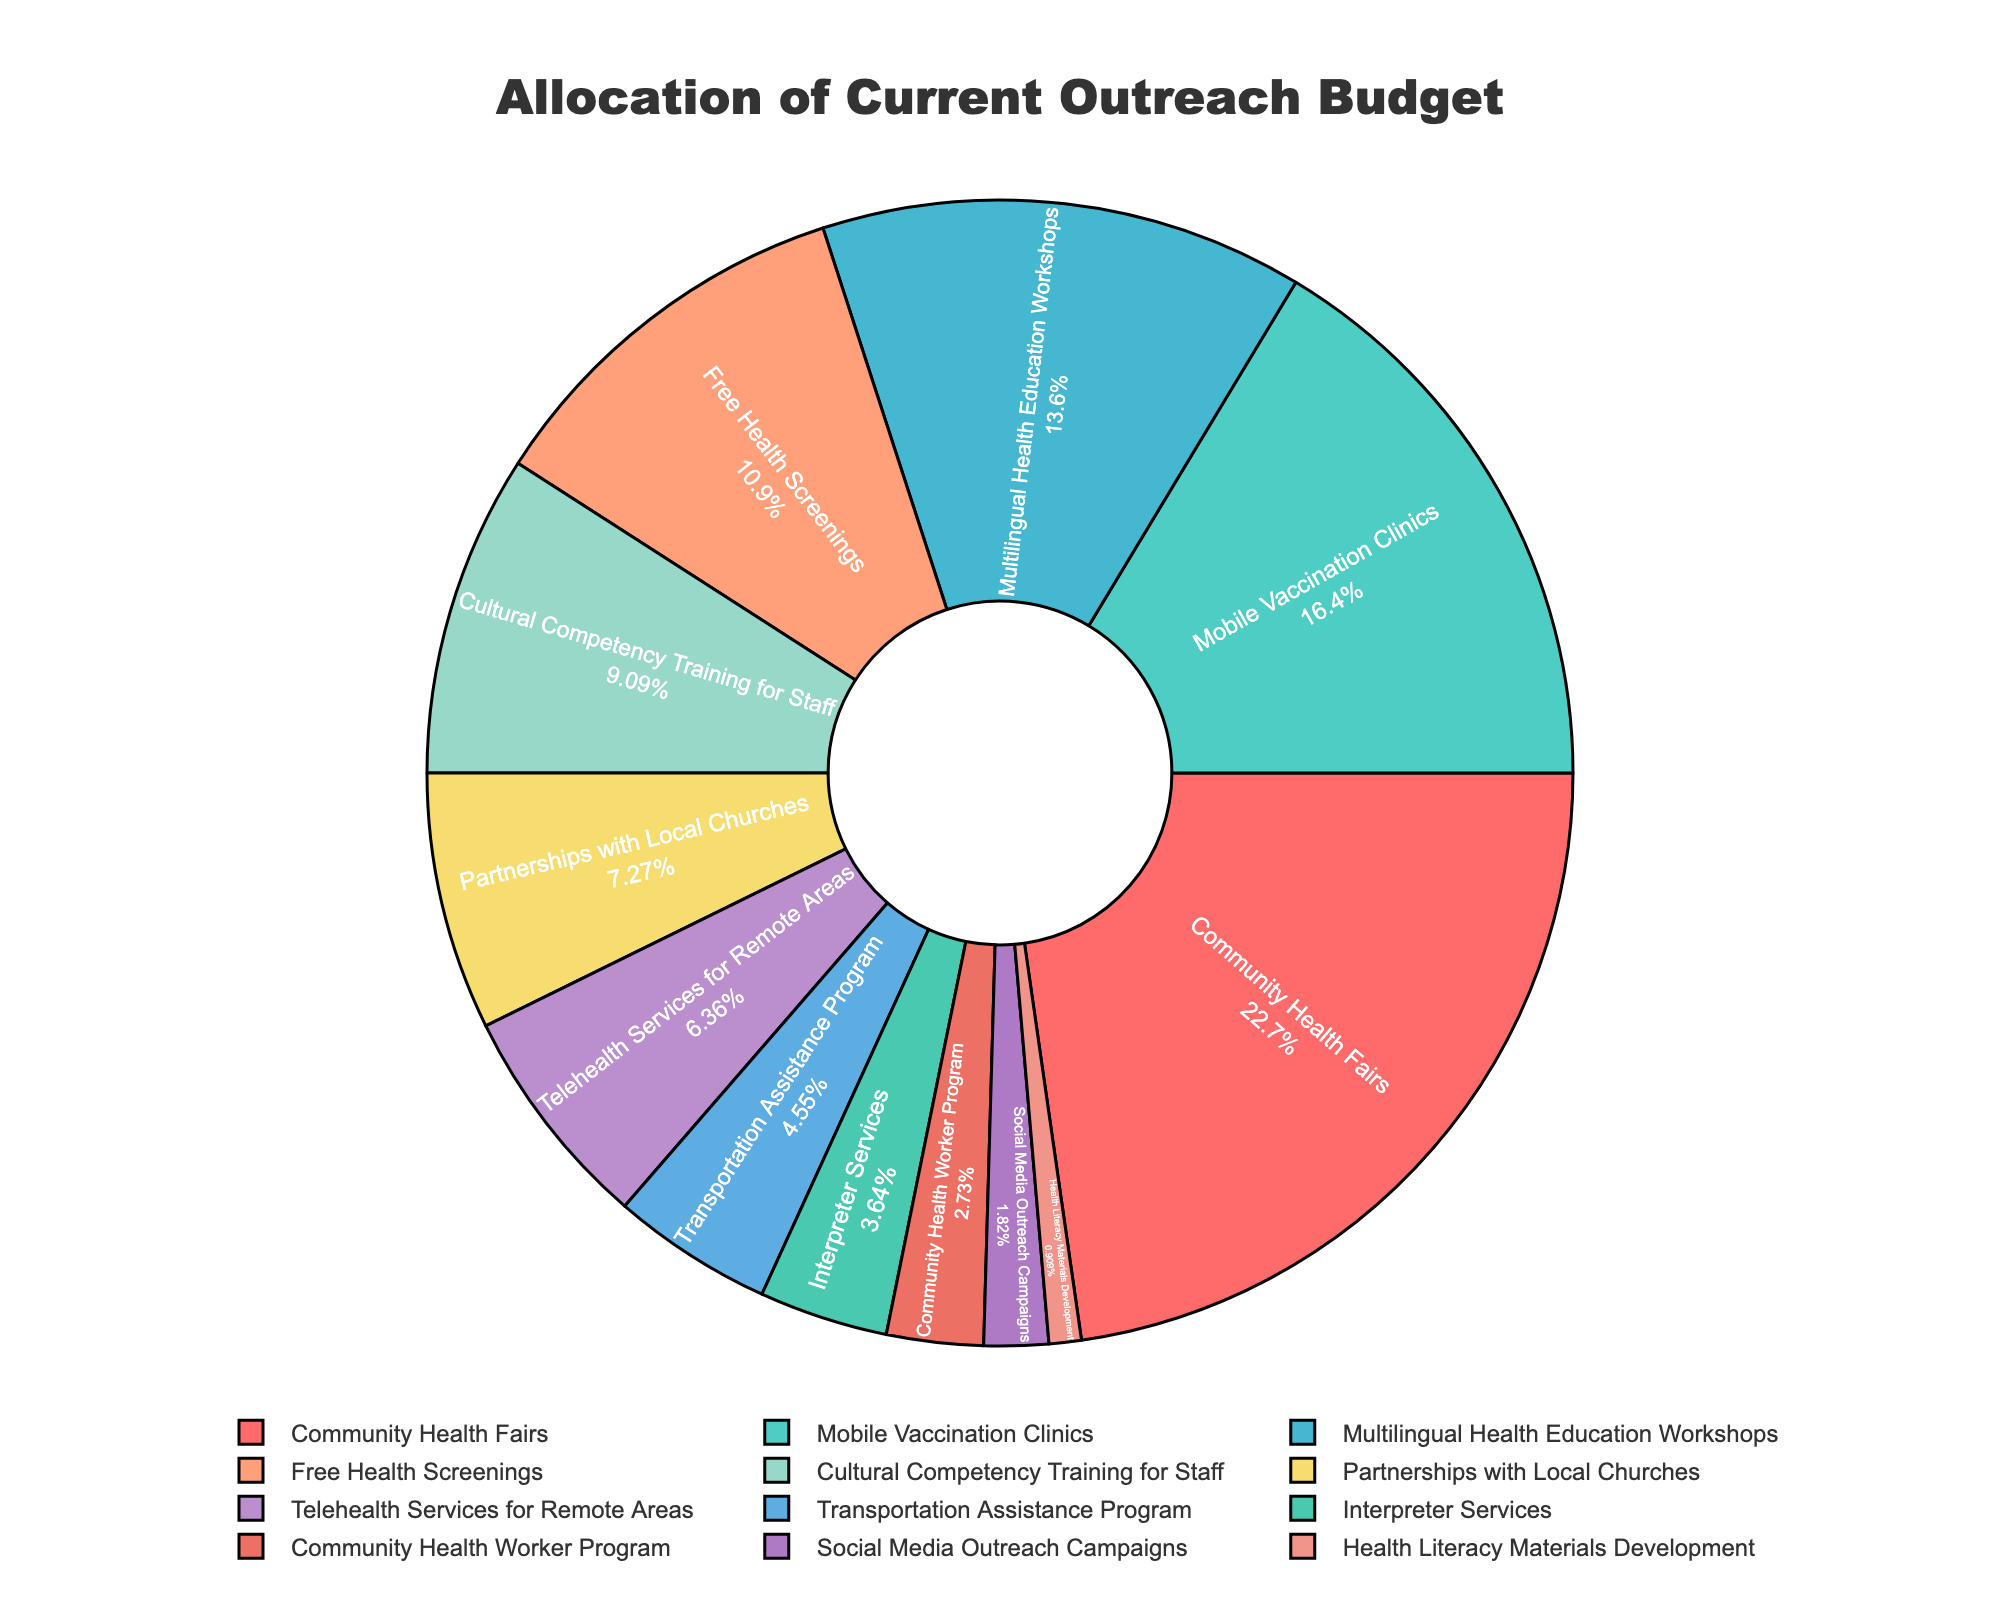What percentage of the total budget is allocated to Mobile Vaccination Clinics? The pie chart shows the percentage of the budget allocated to each program. Locate Mobile Vaccination Clinics, which is labeled inside the pie chart with its percentage.
Answer: 18% Which program has the smallest allocation and what is it? Look for the segment with the smallest percentage in the pie chart. The smallest segment will indicate the program with the least budget allocation.
Answer: Health Literacy Materials Development, 1% Are Community Health Fairs allocated more than double the budget of Interpreter Services? Compare the percentages of Community Health Fairs and Interpreter Services in the pie chart. Community Health Fairs have 25% and Interpreter Services have 4%. Double of Interpreter Services' budget is 8%. 25% > 8%.
Answer: Yes How much more budget is given to Free Health Screenings compared to Transportation Assistance Program? Identify the percentages for both programs on the pie chart. Free Health Screenings have 12% and Transportation Assistance Program has 5%. Calculate the difference: 12% - 5% = 7%.
Answer: 7% Which programs have an allocation percentage between 10% and 20%? Identify programs on the pie chart which have percentages between 10% and 20%. These are Mobile Vaccination Clinics (18%), Multilingual Health Education Workshops (15%), and Free Health Screenings (12%).
Answer: Mobile Vaccination Clinics, Multilingual Health Education Workshops, Free Health Screenings If the total budget is $200,000, what is the budget for Cultural Competency Training for Staff? Cultural Competency Training for Staff has 10% allocation. Calculate 10% of $200,000: 0.10 * 200,000 = $20,000.
Answer: $20,000 Between Partnerships with Local Churches and Social Media Outreach Campaigns, which has a higher budget allocation and by how much? Compare the percentages from the pie chart. Partnerships with Local Churches have 8% and Social Media Outreach Campaigns have 2%. 8% - 2% = 6%.
Answer: Partnerships with Local Churches, by 6% What is the combined budget allocation of Telehealth Services for Remote Areas and Interpreter Services? Locate both programs on the pie chart. Telehealth Services for Remote Areas have 7% and Interpreter Services have 4%. Sum these percentages: 7% + 4% = 11%.
Answer: 11% How many programs have a budget less than or equal to 5%? Count the number of programs in the pie chart with percentages less than or equal to 5%. These are Transportation Assistance Program (5%), Interpreter Services (4%), Community Health Worker Program (3%), Social Media Outreach Campaigns (2%), and Health Literacy Materials Development (1%). Total is 5 programs.
Answer: 5 programs 